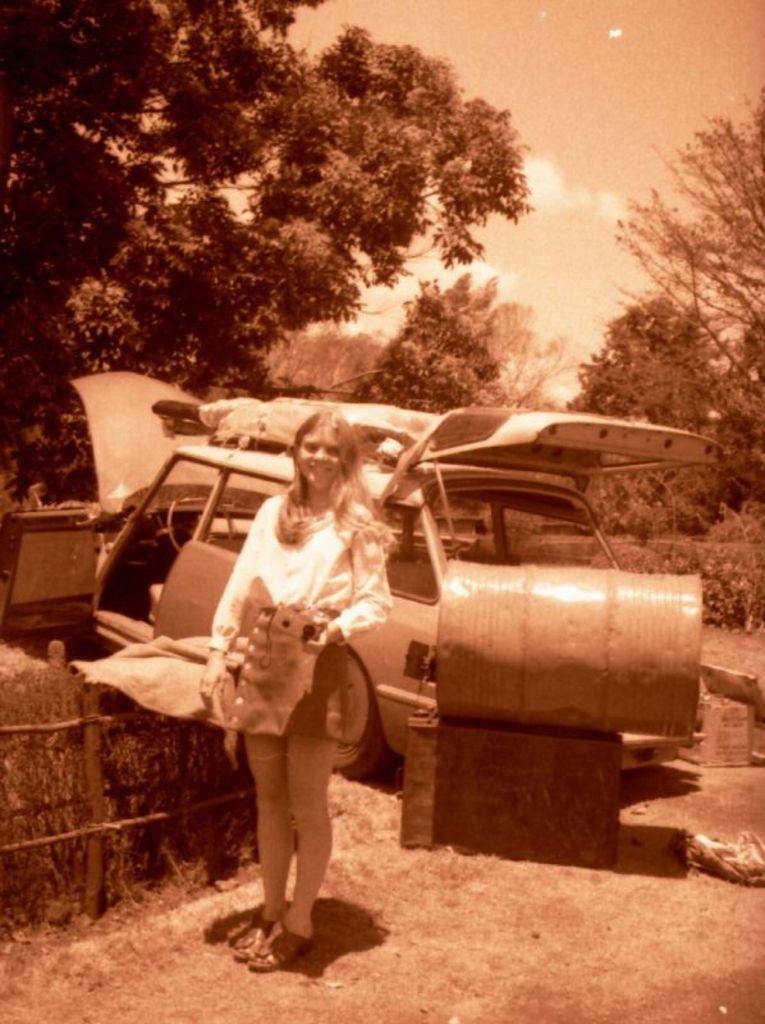Describe this image in one or two sentences. In the center of the image there is a girl standing. In the background of the image there are trees. There is a car. There is a barrel. There is sky. At the bottom of the image there is ground. There is a wooden fencing at the left side of the image. 